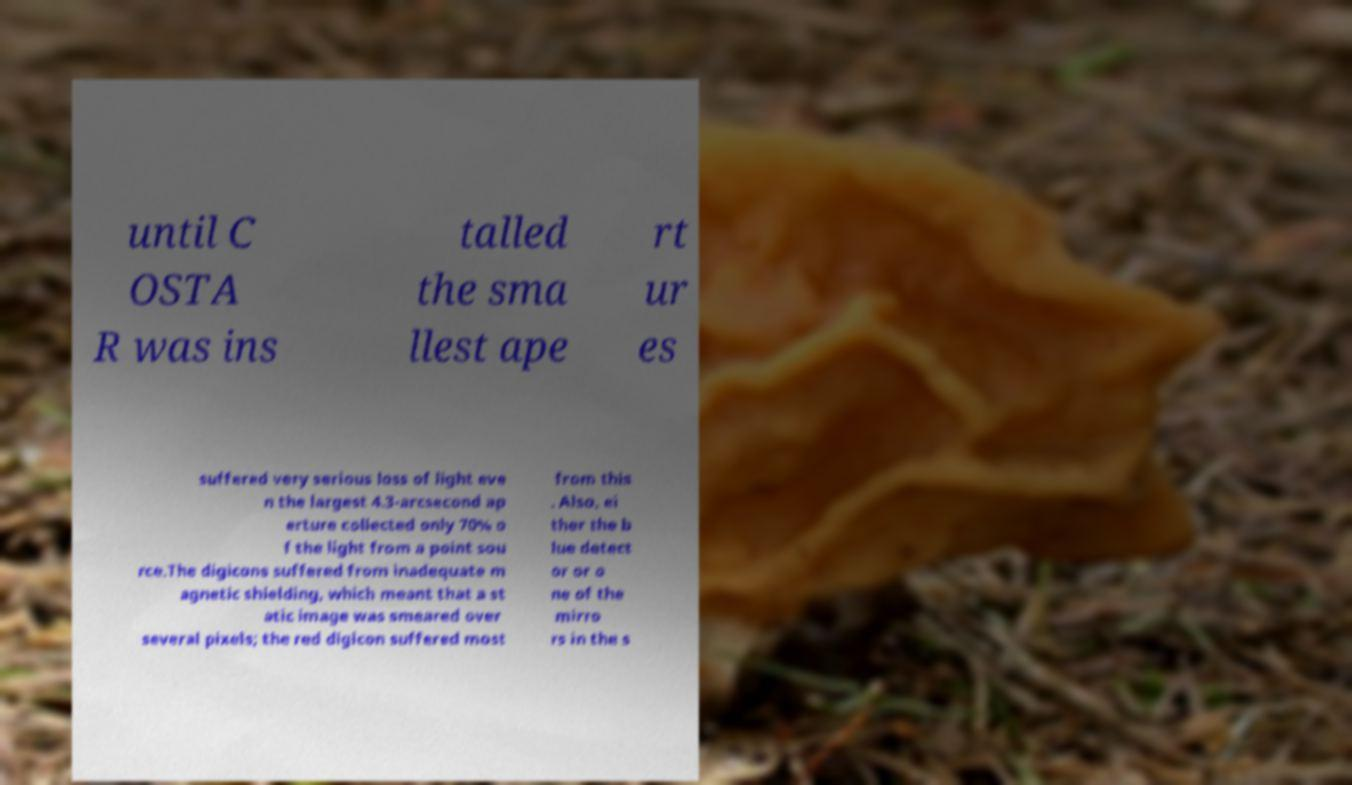There's text embedded in this image that I need extracted. Can you transcribe it verbatim? until C OSTA R was ins talled the sma llest ape rt ur es suffered very serious loss of light eve n the largest 4.3-arcsecond ap erture collected only 70% o f the light from a point sou rce.The digicons suffered from inadequate m agnetic shielding, which meant that a st atic image was smeared over several pixels; the red digicon suffered most from this . Also, ei ther the b lue detect or or o ne of the mirro rs in the s 